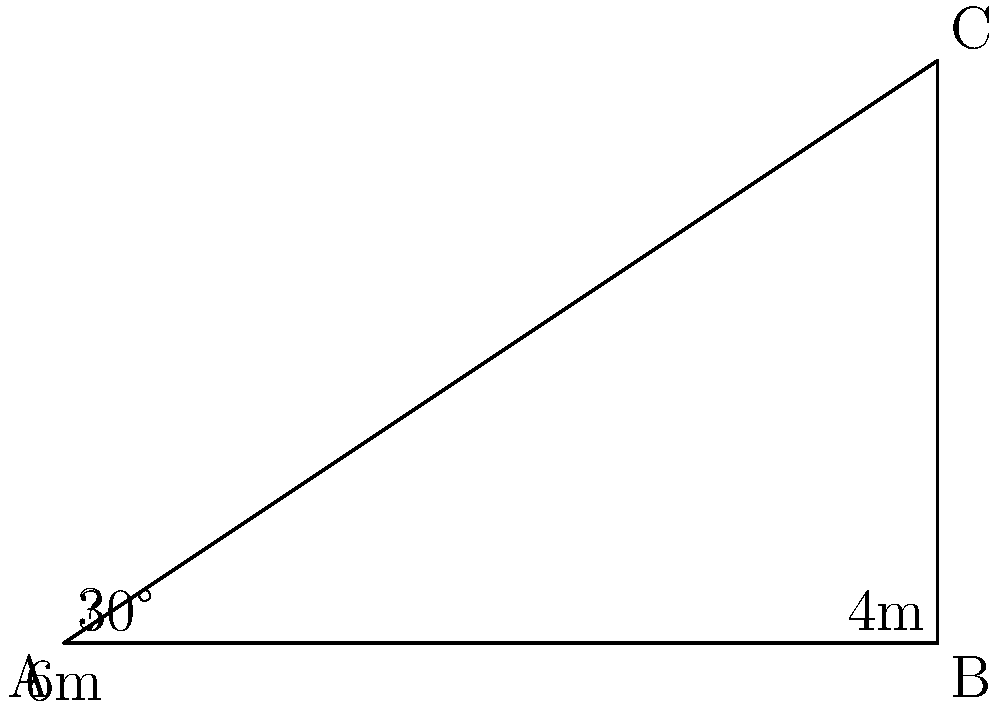A temporary structure requires support cables to be attached from the ground to the top of a vertical pole. The pole is 4 meters high, and the cable needs to be attached at a 30-degree angle from the ground. What length of cable is required for this support structure? To solve this problem, we'll use trigonometry. Let's break it down step-by-step:

1) We have a right triangle where:
   - The adjacent side (ground distance) is unknown
   - The opposite side (height of the pole) is 4 meters
   - The angle between the cable and the ground is 30°

2) We can use the tangent function to find the ground distance:
   $$\tan(30°) = \frac{opposite}{adjacent} = \frac{4}{adjacent}$$

3) Solving for the adjacent side:
   $$adjacent = \frac{4}{\tan(30°)} \approx 6.93\text{ meters}$$

4) Now we have a right triangle where we know:
   - The adjacent side (ground distance) ≈ 6.93 meters
   - The opposite side (height) = 4 meters

5) To find the length of the cable (hypotenuse), we can use the Pythagorean theorem:
   $$cable^2 = 6.93^2 + 4^2$$

6) Solving for the cable length:
   $$cable = \sqrt{6.93^2 + 4^2} \approx 8\text{ meters}$$

Therefore, the required length of the support cable is approximately 8 meters.
Answer: 8 meters 